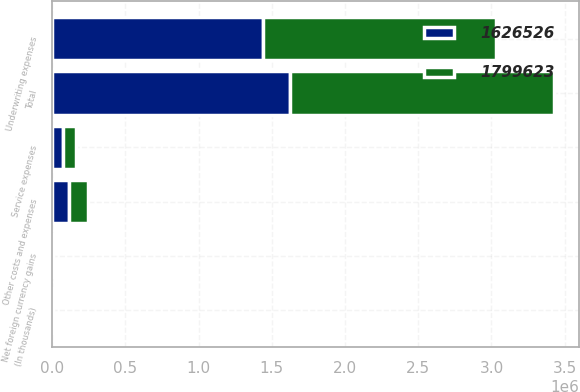Convert chart. <chart><loc_0><loc_0><loc_500><loc_500><stacked_bar_chart><ecel><fcel>(In thousands)<fcel>Underwriting expenses<fcel>Service expenses<fcel>Net foreign currency gains<fcel>Other costs and expenses<fcel>Total<nl><fcel>1.79962e+06<fcel>2012<fcel>1.59275e+06<fcel>84986<fcel>6092<fcel>127983<fcel>1.79962e+06<nl><fcel>1.62653e+06<fcel>2011<fcel>1.43813e+06<fcel>75231<fcel>1884<fcel>115050<fcel>1.62653e+06<nl></chart> 